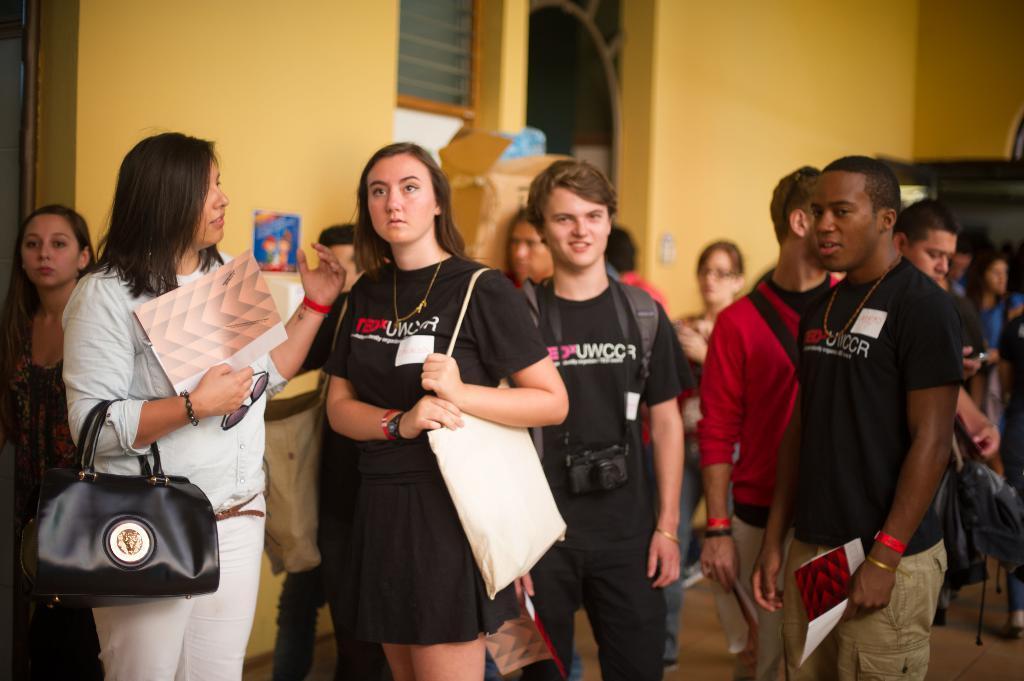Can you describe this image briefly? In this picture we can see a group of people standing and holding the backpacks and papers in their hands. 